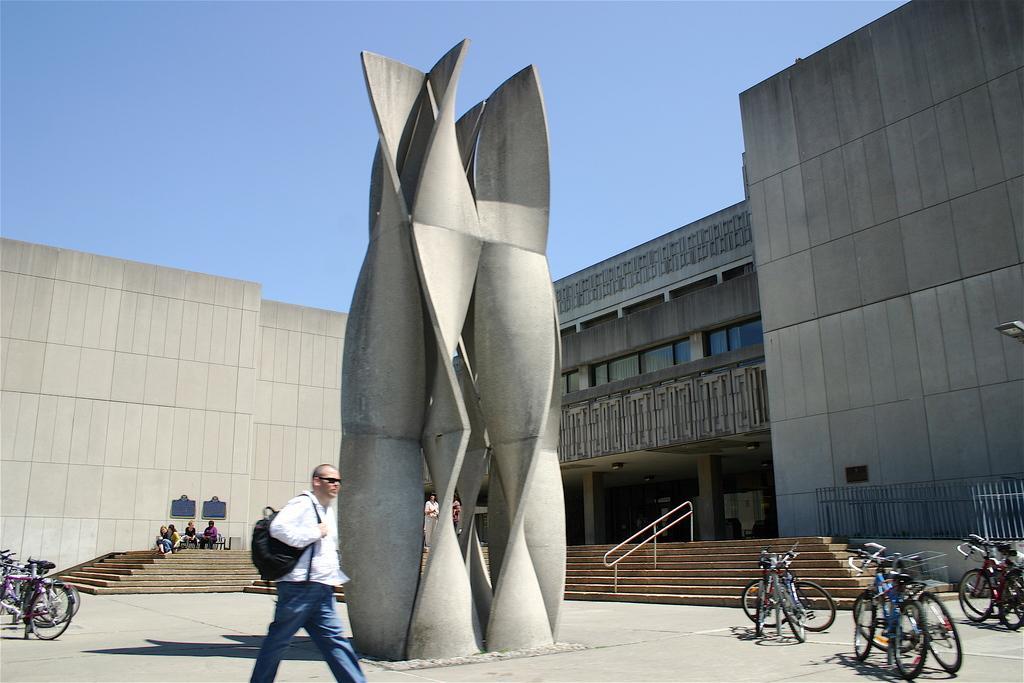In one or two sentences, can you explain what this image depicts? In the image in the center we can see one person walking and he is wearing backpack. And we can see thin shell structures. In the background there is a sky,building,wall,staircase,fence,cycles and few people were sitting. 